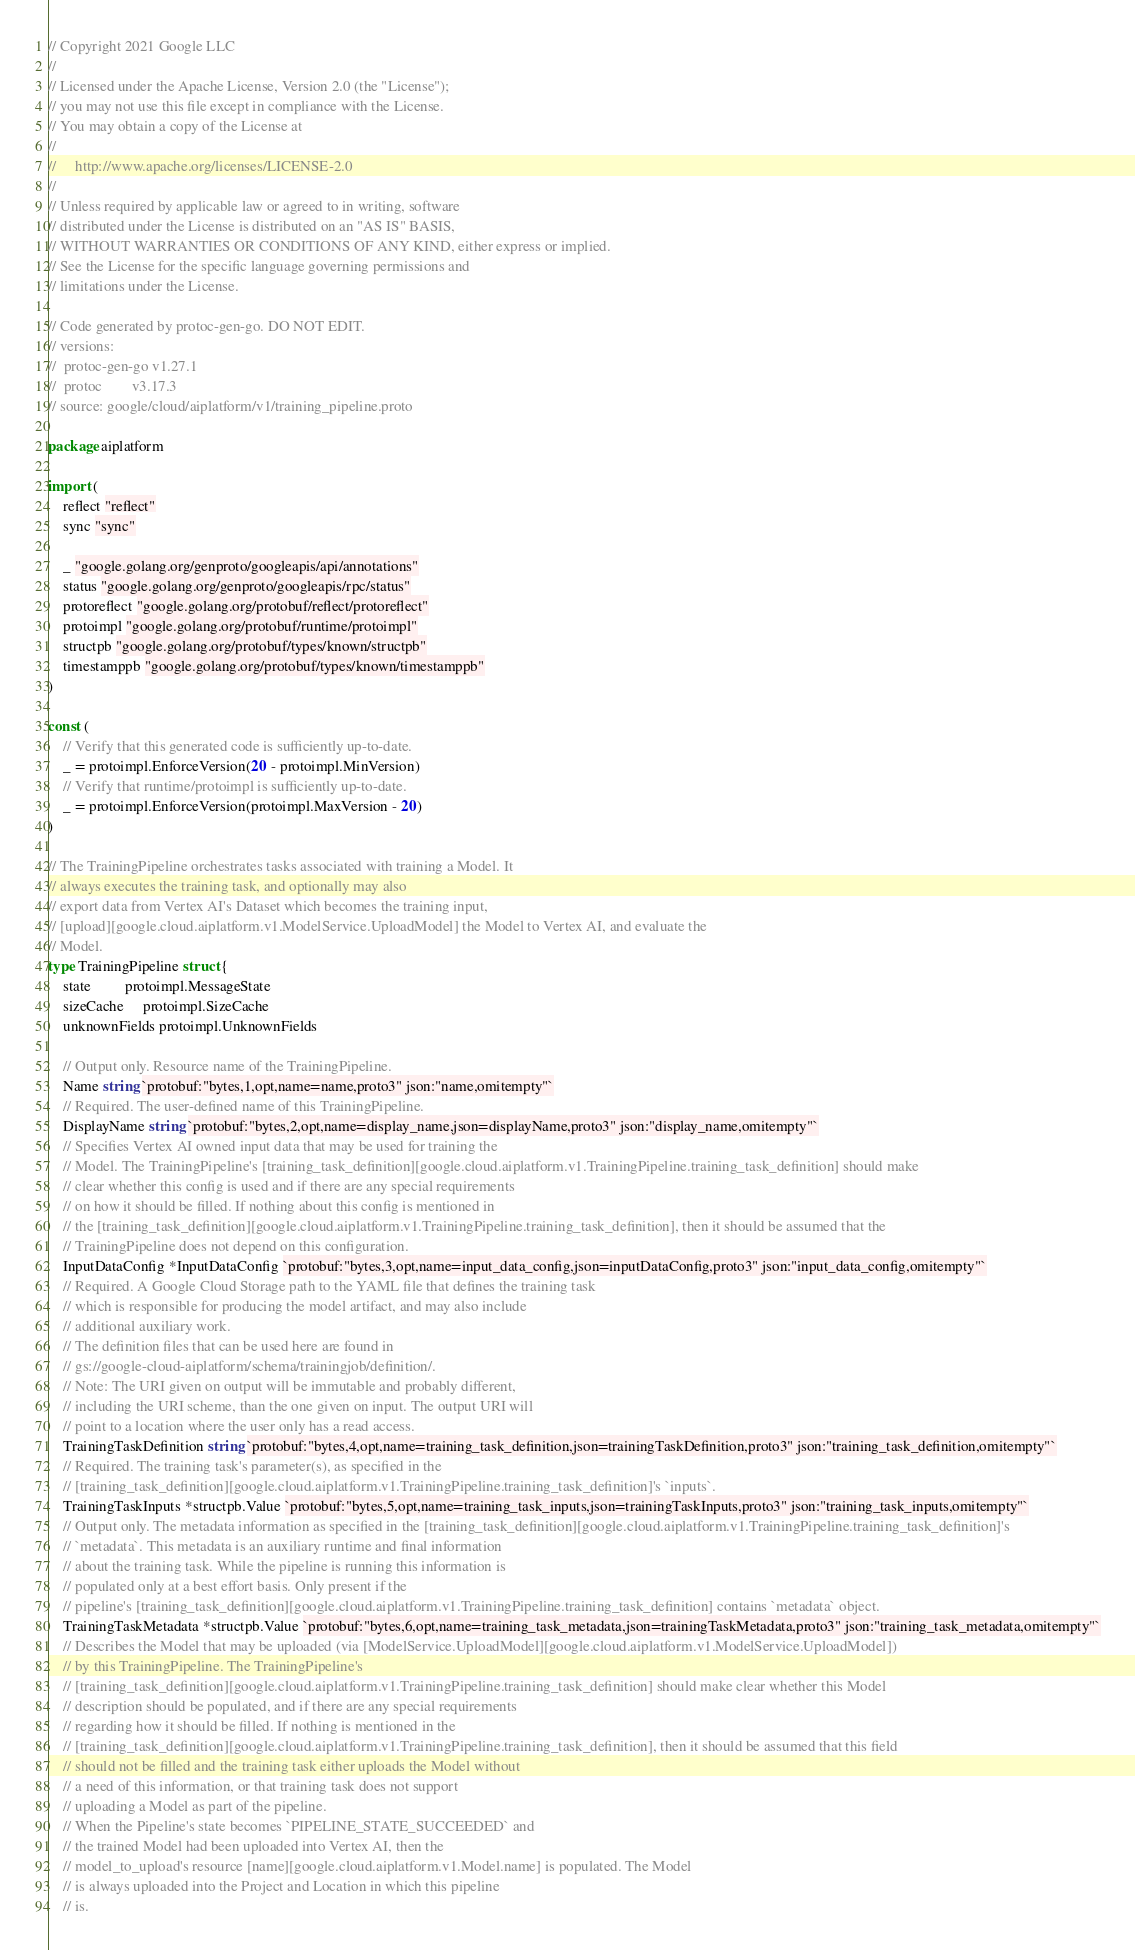Convert code to text. <code><loc_0><loc_0><loc_500><loc_500><_Go_>// Copyright 2021 Google LLC
//
// Licensed under the Apache License, Version 2.0 (the "License");
// you may not use this file except in compliance with the License.
// You may obtain a copy of the License at
//
//     http://www.apache.org/licenses/LICENSE-2.0
//
// Unless required by applicable law or agreed to in writing, software
// distributed under the License is distributed on an "AS IS" BASIS,
// WITHOUT WARRANTIES OR CONDITIONS OF ANY KIND, either express or implied.
// See the License for the specific language governing permissions and
// limitations under the License.

// Code generated by protoc-gen-go. DO NOT EDIT.
// versions:
// 	protoc-gen-go v1.27.1
// 	protoc        v3.17.3
// source: google/cloud/aiplatform/v1/training_pipeline.proto

package aiplatform

import (
	reflect "reflect"
	sync "sync"

	_ "google.golang.org/genproto/googleapis/api/annotations"
	status "google.golang.org/genproto/googleapis/rpc/status"
	protoreflect "google.golang.org/protobuf/reflect/protoreflect"
	protoimpl "google.golang.org/protobuf/runtime/protoimpl"
	structpb "google.golang.org/protobuf/types/known/structpb"
	timestamppb "google.golang.org/protobuf/types/known/timestamppb"
)

const (
	// Verify that this generated code is sufficiently up-to-date.
	_ = protoimpl.EnforceVersion(20 - protoimpl.MinVersion)
	// Verify that runtime/protoimpl is sufficiently up-to-date.
	_ = protoimpl.EnforceVersion(protoimpl.MaxVersion - 20)
)

// The TrainingPipeline orchestrates tasks associated with training a Model. It
// always executes the training task, and optionally may also
// export data from Vertex AI's Dataset which becomes the training input,
// [upload][google.cloud.aiplatform.v1.ModelService.UploadModel] the Model to Vertex AI, and evaluate the
// Model.
type TrainingPipeline struct {
	state         protoimpl.MessageState
	sizeCache     protoimpl.SizeCache
	unknownFields protoimpl.UnknownFields

	// Output only. Resource name of the TrainingPipeline.
	Name string `protobuf:"bytes,1,opt,name=name,proto3" json:"name,omitempty"`
	// Required. The user-defined name of this TrainingPipeline.
	DisplayName string `protobuf:"bytes,2,opt,name=display_name,json=displayName,proto3" json:"display_name,omitempty"`
	// Specifies Vertex AI owned input data that may be used for training the
	// Model. The TrainingPipeline's [training_task_definition][google.cloud.aiplatform.v1.TrainingPipeline.training_task_definition] should make
	// clear whether this config is used and if there are any special requirements
	// on how it should be filled. If nothing about this config is mentioned in
	// the [training_task_definition][google.cloud.aiplatform.v1.TrainingPipeline.training_task_definition], then it should be assumed that the
	// TrainingPipeline does not depend on this configuration.
	InputDataConfig *InputDataConfig `protobuf:"bytes,3,opt,name=input_data_config,json=inputDataConfig,proto3" json:"input_data_config,omitempty"`
	// Required. A Google Cloud Storage path to the YAML file that defines the training task
	// which is responsible for producing the model artifact, and may also include
	// additional auxiliary work.
	// The definition files that can be used here are found in
	// gs://google-cloud-aiplatform/schema/trainingjob/definition/.
	// Note: The URI given on output will be immutable and probably different,
	// including the URI scheme, than the one given on input. The output URI will
	// point to a location where the user only has a read access.
	TrainingTaskDefinition string `protobuf:"bytes,4,opt,name=training_task_definition,json=trainingTaskDefinition,proto3" json:"training_task_definition,omitempty"`
	// Required. The training task's parameter(s), as specified in the
	// [training_task_definition][google.cloud.aiplatform.v1.TrainingPipeline.training_task_definition]'s `inputs`.
	TrainingTaskInputs *structpb.Value `protobuf:"bytes,5,opt,name=training_task_inputs,json=trainingTaskInputs,proto3" json:"training_task_inputs,omitempty"`
	// Output only. The metadata information as specified in the [training_task_definition][google.cloud.aiplatform.v1.TrainingPipeline.training_task_definition]'s
	// `metadata`. This metadata is an auxiliary runtime and final information
	// about the training task. While the pipeline is running this information is
	// populated only at a best effort basis. Only present if the
	// pipeline's [training_task_definition][google.cloud.aiplatform.v1.TrainingPipeline.training_task_definition] contains `metadata` object.
	TrainingTaskMetadata *structpb.Value `protobuf:"bytes,6,opt,name=training_task_metadata,json=trainingTaskMetadata,proto3" json:"training_task_metadata,omitempty"`
	// Describes the Model that may be uploaded (via [ModelService.UploadModel][google.cloud.aiplatform.v1.ModelService.UploadModel])
	// by this TrainingPipeline. The TrainingPipeline's
	// [training_task_definition][google.cloud.aiplatform.v1.TrainingPipeline.training_task_definition] should make clear whether this Model
	// description should be populated, and if there are any special requirements
	// regarding how it should be filled. If nothing is mentioned in the
	// [training_task_definition][google.cloud.aiplatform.v1.TrainingPipeline.training_task_definition], then it should be assumed that this field
	// should not be filled and the training task either uploads the Model without
	// a need of this information, or that training task does not support
	// uploading a Model as part of the pipeline.
	// When the Pipeline's state becomes `PIPELINE_STATE_SUCCEEDED` and
	// the trained Model had been uploaded into Vertex AI, then the
	// model_to_upload's resource [name][google.cloud.aiplatform.v1.Model.name] is populated. The Model
	// is always uploaded into the Project and Location in which this pipeline
	// is.</code> 